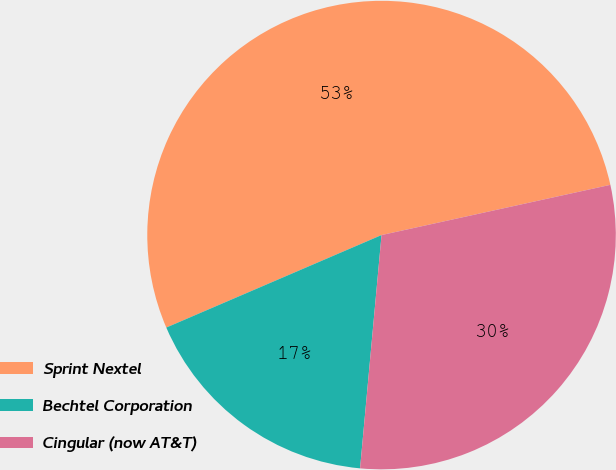Convert chart. <chart><loc_0><loc_0><loc_500><loc_500><pie_chart><fcel>Sprint Nextel<fcel>Bechtel Corporation<fcel>Cingular (now AT&T)<nl><fcel>53.02%<fcel>17.08%<fcel>29.9%<nl></chart> 